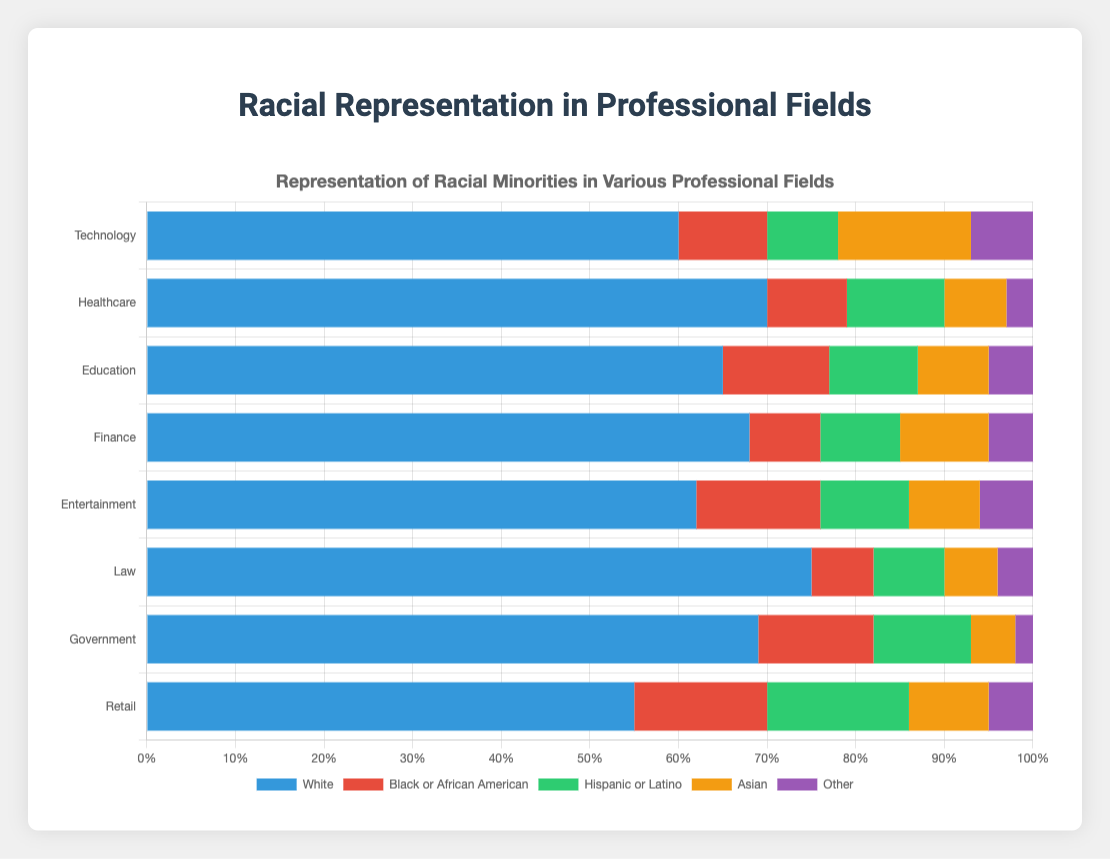What's the total percentage of racial minorities (excluding White) in the Technology field? To find the total percentage of racial minorities in the Technology field, sum the percentages of Black or African American, Hispanic or Latino, Asian, and Other. 10% + 8% + 15% + 7% = 40%
Answer: 40% Which field has the highest percentage of Black or African American representation? By examining the chart, the field with the tallest red bar (representing Black or African American) is Retail, standing at 15%.
Answer: Retail Is the percentage of Hispanic or Latino in Healthcare greater than the percentage of Asian in Finance? According to the chart, Hispanic or Latino in Healthcare is 11%, and Asian in Finance is 10%. Comparing these values, 11% is greater than 10%.
Answer: Yes What's the difference in percentage between White and Black or African American representation in Education? The percentages for White and Black or African American representation in Education are 65% and 12%, respectively. The difference is 65% - 12% = 53%.
Answer: 53% Which field shows the most diversity (i.e., the smallest percentage of White individuals)? The field with the smallest blue section (representing White) is Retail, with 55%.
Answer: Retail What's the average percentage of Asian representation across all fields? To compute the average, sum the Asian percentages across all fields and then divide by the number of fields. (15 + 7 + 8 + 10 + 8 + 6 + 5 + 9)/8 = 68/8 = 8.5%
Answer: 8.5% Are there more Hispanics or Latinos in Retail compared to Entertainment? From the chart, Retail has a green bar representing 16% for Hispanic or Latino, while Entertainment has a green bar representing 10%. 16% > 10%.
Answer: Yes Compare the percentage of White individuals in Technology and Law. The chart shows White individuals in Technology at 60% and in Law at 75%. 75% is greater than 60%.
Answer: Law What is the combined percentage of Black or African American and Hispanic or Latino in Government? The chart indicates 13% for Black or African American and 11% for Hispanic or Latino in Government. Combined, this is 13% + 11% = 24%.
Answer: 24% Which racial group has the least representation in Technology? By checking the chart, the "Other" category in Technology has the smallest bar, representing 7%.
Answer: Other 